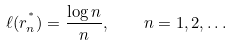<formula> <loc_0><loc_0><loc_500><loc_500>\ell ( r ^ { ^ { * } } _ { n } ) = \frac { \log n } { n } , \quad n = 1 , 2 , \dots</formula> 